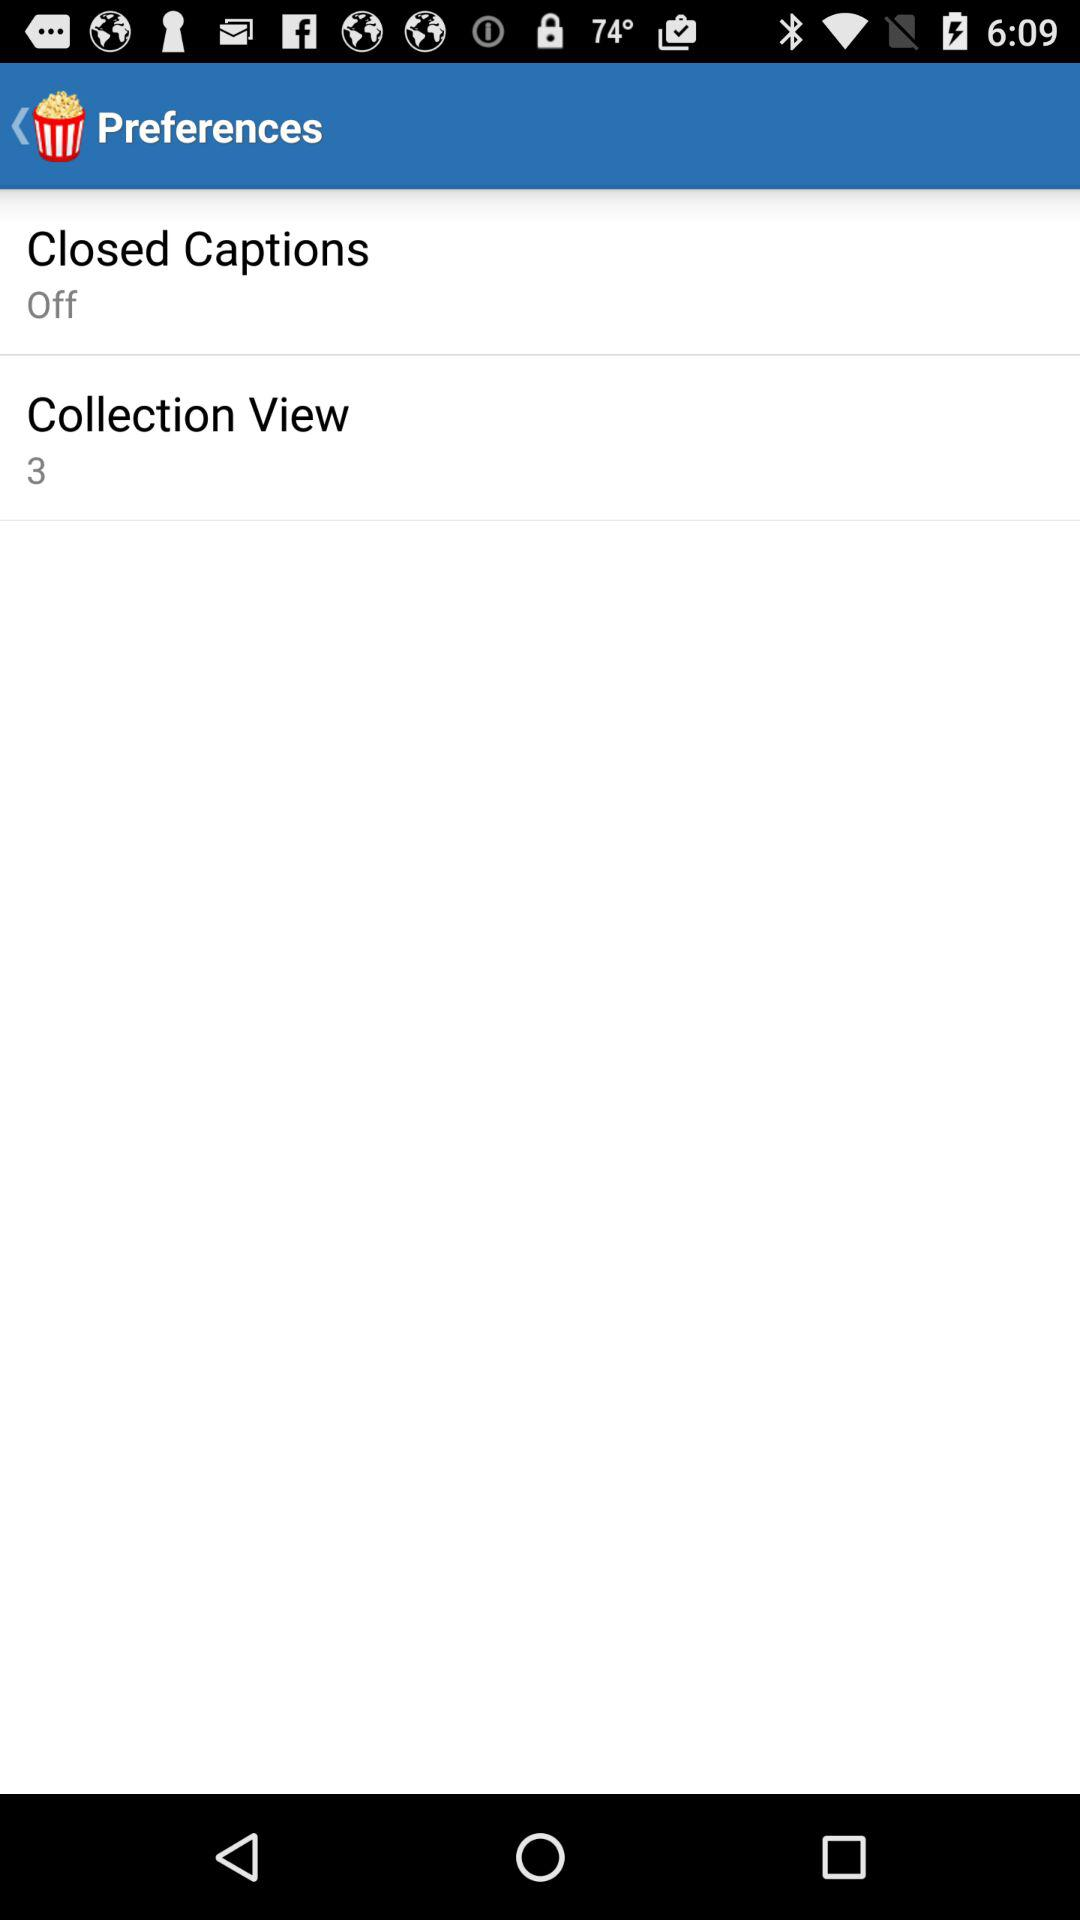What are the settings for "Closed Captions"? The setting for "Closed Captions" is "Off". 